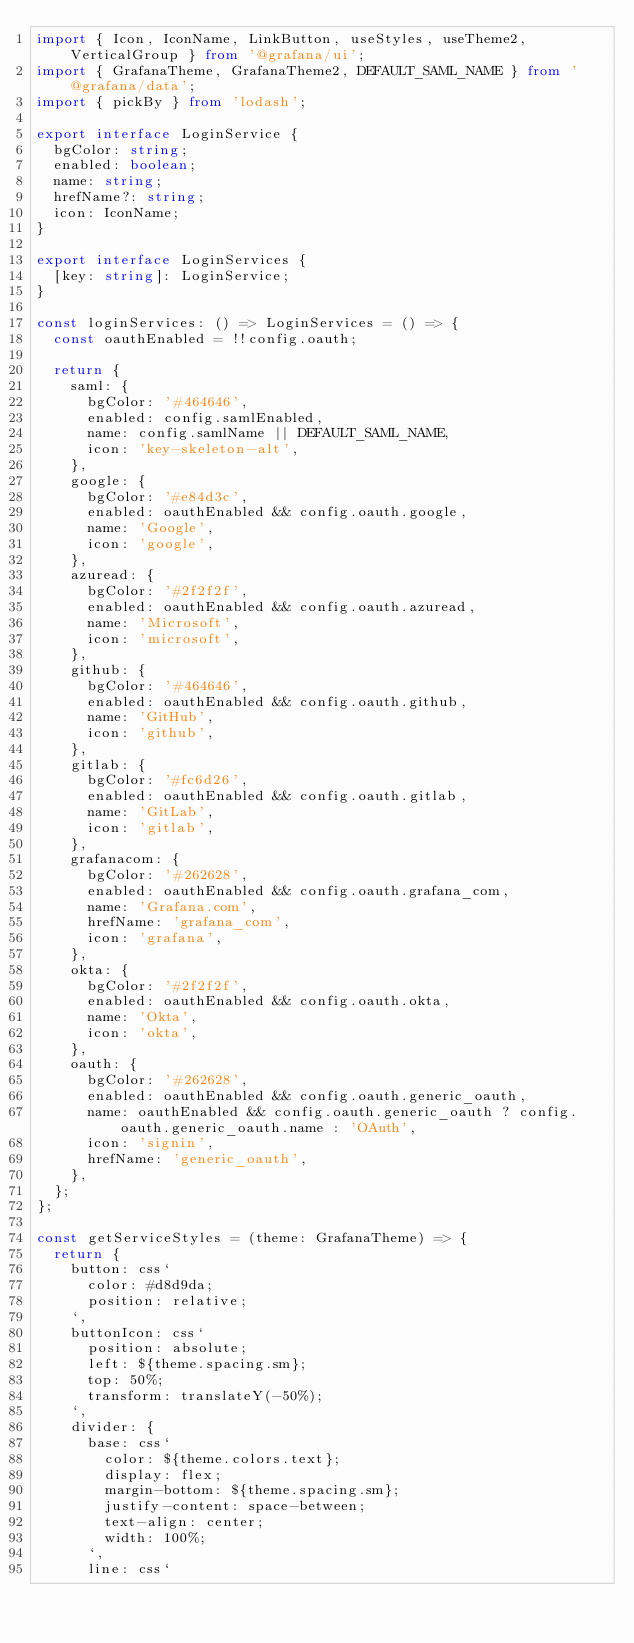Convert code to text. <code><loc_0><loc_0><loc_500><loc_500><_TypeScript_>import { Icon, IconName, LinkButton, useStyles, useTheme2, VerticalGroup } from '@grafana/ui';
import { GrafanaTheme, GrafanaTheme2, DEFAULT_SAML_NAME } from '@grafana/data';
import { pickBy } from 'lodash';

export interface LoginService {
  bgColor: string;
  enabled: boolean;
  name: string;
  hrefName?: string;
  icon: IconName;
}

export interface LoginServices {
  [key: string]: LoginService;
}

const loginServices: () => LoginServices = () => {
  const oauthEnabled = !!config.oauth;

  return {
    saml: {
      bgColor: '#464646',
      enabled: config.samlEnabled,
      name: config.samlName || DEFAULT_SAML_NAME,
      icon: 'key-skeleton-alt',
    },
    google: {
      bgColor: '#e84d3c',
      enabled: oauthEnabled && config.oauth.google,
      name: 'Google',
      icon: 'google',
    },
    azuread: {
      bgColor: '#2f2f2f',
      enabled: oauthEnabled && config.oauth.azuread,
      name: 'Microsoft',
      icon: 'microsoft',
    },
    github: {
      bgColor: '#464646',
      enabled: oauthEnabled && config.oauth.github,
      name: 'GitHub',
      icon: 'github',
    },
    gitlab: {
      bgColor: '#fc6d26',
      enabled: oauthEnabled && config.oauth.gitlab,
      name: 'GitLab',
      icon: 'gitlab',
    },
    grafanacom: {
      bgColor: '#262628',
      enabled: oauthEnabled && config.oauth.grafana_com,
      name: 'Grafana.com',
      hrefName: 'grafana_com',
      icon: 'grafana',
    },
    okta: {
      bgColor: '#2f2f2f',
      enabled: oauthEnabled && config.oauth.okta,
      name: 'Okta',
      icon: 'okta',
    },
    oauth: {
      bgColor: '#262628',
      enabled: oauthEnabled && config.oauth.generic_oauth,
      name: oauthEnabled && config.oauth.generic_oauth ? config.oauth.generic_oauth.name : 'OAuth',
      icon: 'signin',
      hrefName: 'generic_oauth',
    },
  };
};

const getServiceStyles = (theme: GrafanaTheme) => {
  return {
    button: css`
      color: #d8d9da;
      position: relative;
    `,
    buttonIcon: css`
      position: absolute;
      left: ${theme.spacing.sm};
      top: 50%;
      transform: translateY(-50%);
    `,
    divider: {
      base: css`
        color: ${theme.colors.text};
        display: flex;
        margin-bottom: ${theme.spacing.sm};
        justify-content: space-between;
        text-align: center;
        width: 100%;
      `,
      line: css`</code> 